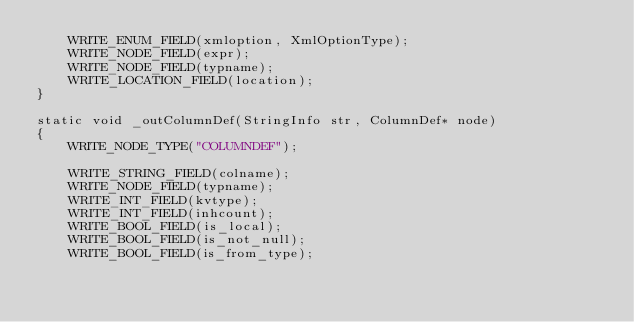Convert code to text. <code><loc_0><loc_0><loc_500><loc_500><_C++_>    WRITE_ENUM_FIELD(xmloption, XmlOptionType);
    WRITE_NODE_FIELD(expr);
    WRITE_NODE_FIELD(typname);
    WRITE_LOCATION_FIELD(location);
}

static void _outColumnDef(StringInfo str, ColumnDef* node)
{
    WRITE_NODE_TYPE("COLUMNDEF");

    WRITE_STRING_FIELD(colname);
    WRITE_NODE_FIELD(typname);
    WRITE_INT_FIELD(kvtype);
    WRITE_INT_FIELD(inhcount);
    WRITE_BOOL_FIELD(is_local);
    WRITE_BOOL_FIELD(is_not_null);
    WRITE_BOOL_FIELD(is_from_type);</code> 